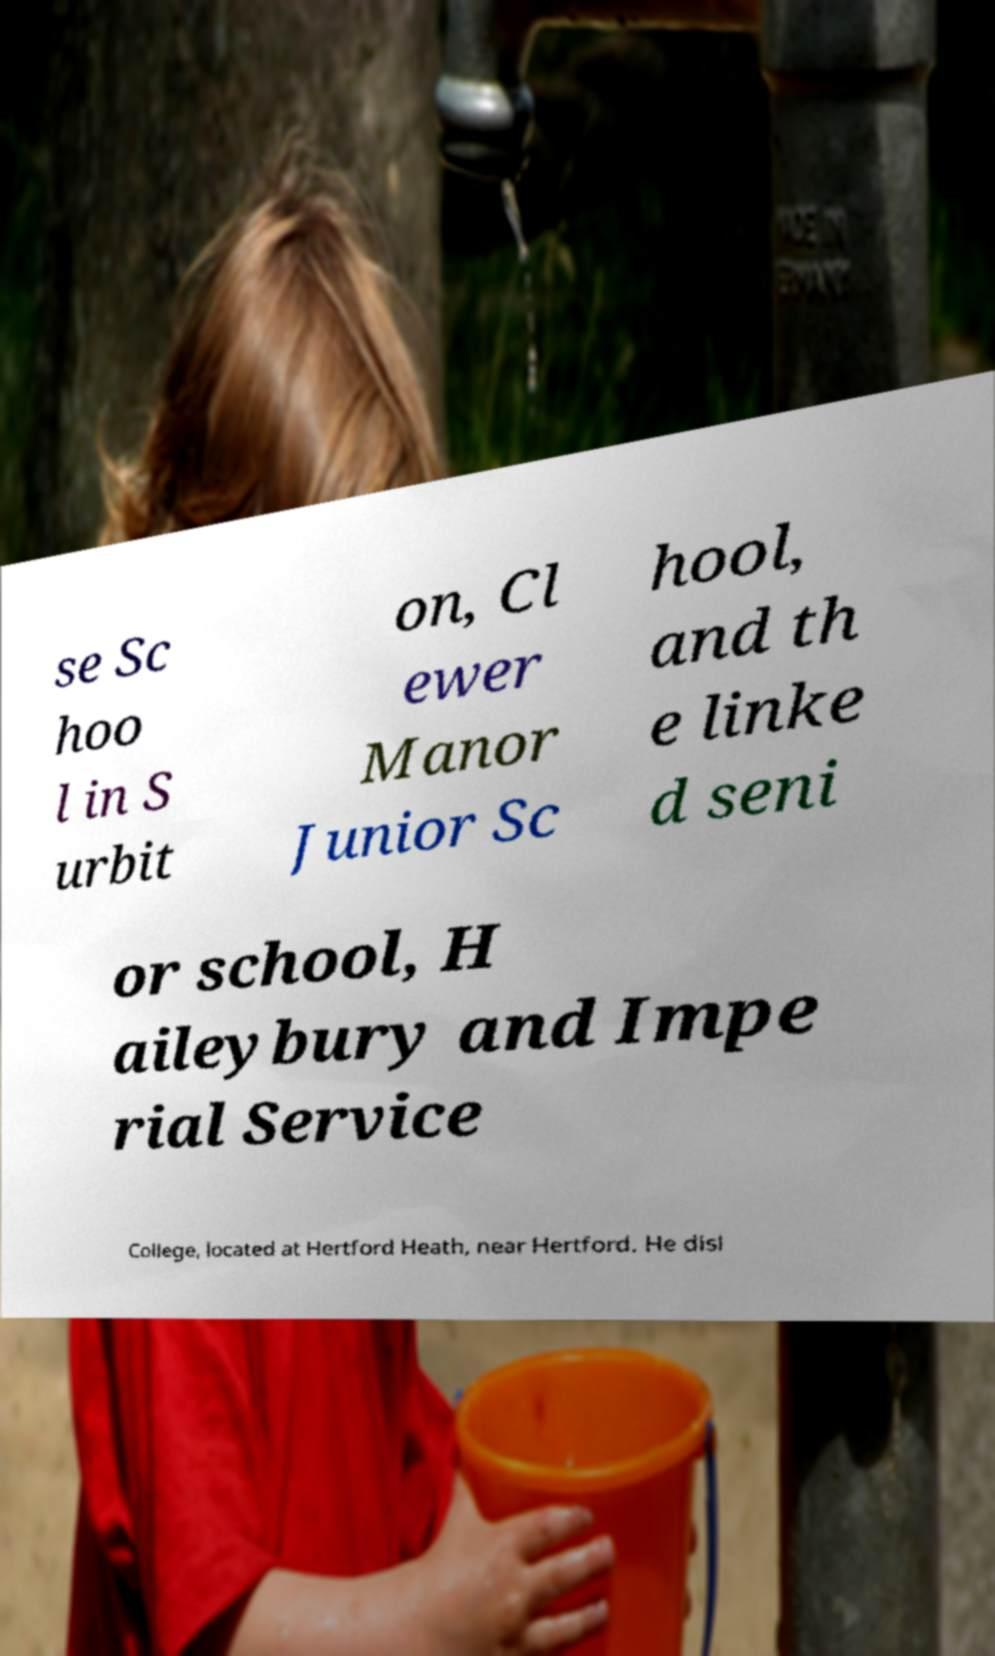Could you extract and type out the text from this image? se Sc hoo l in S urbit on, Cl ewer Manor Junior Sc hool, and th e linke d seni or school, H aileybury and Impe rial Service College, located at Hertford Heath, near Hertford. He disl 